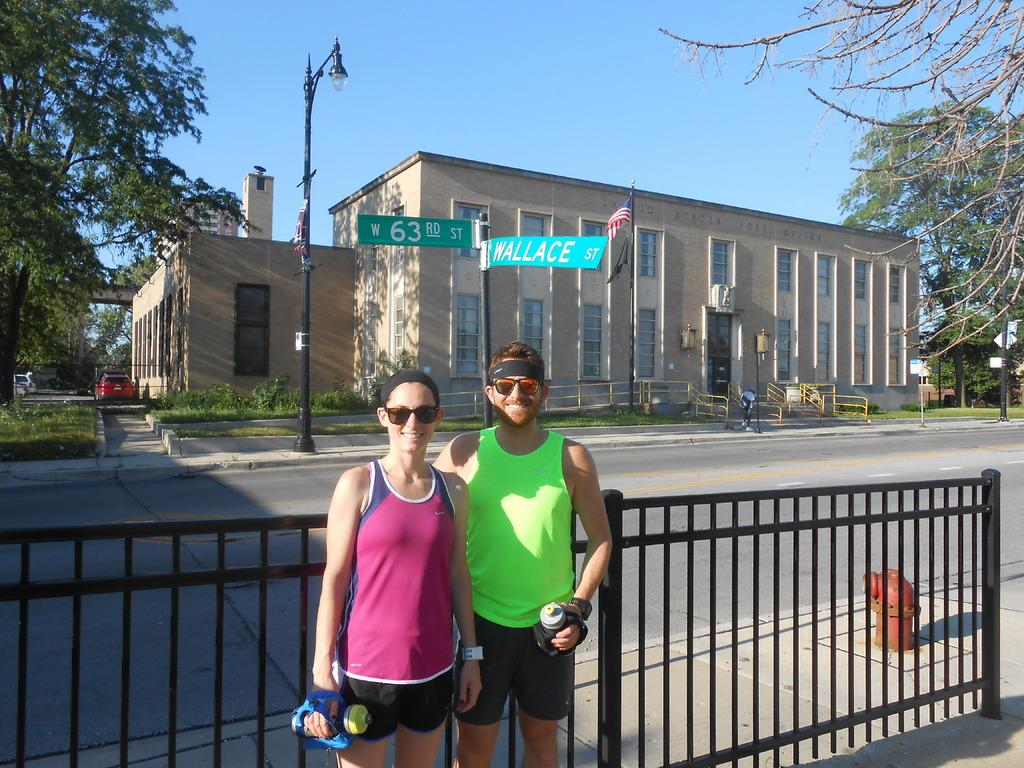Who can be seen in the foreground of the image? There is a man and a woman in the foreground of the image. What are they standing in front of? They are standing in front of a railing. What can be seen in the background of the image? There is a road, poles, boards, trees, vehicles, a building, and the sky visible in the background of the image. What type of cracker is being used to prop up the building in the image? There is no cracker present in the image, and the building is not being propped up by any object. What plastic materials can be seen in the image? There is no plastic material visible in the image. 